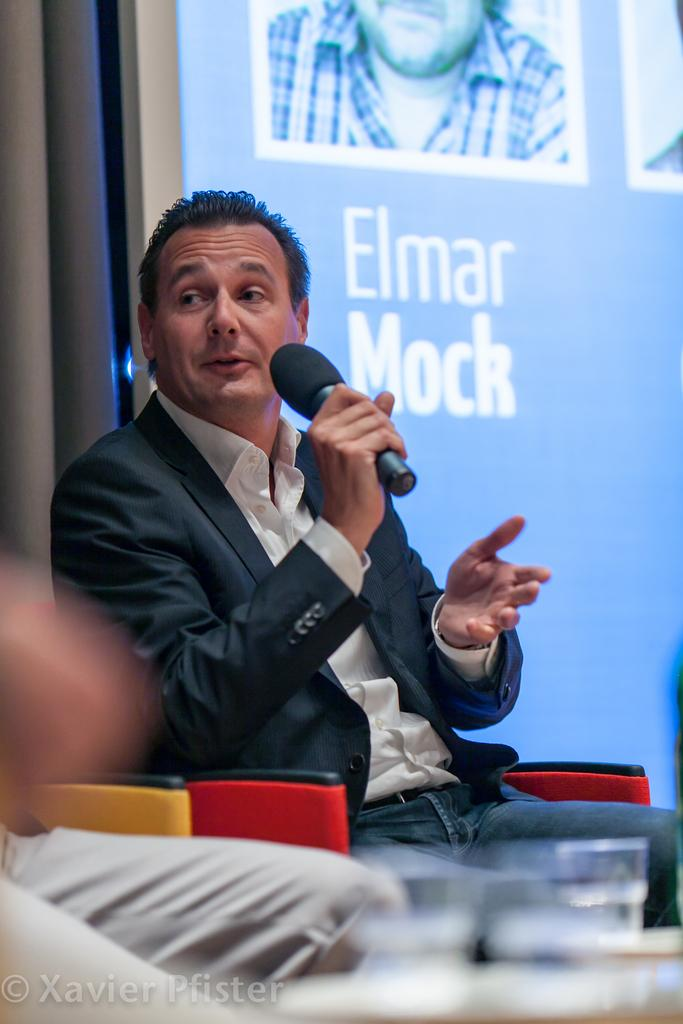Who is the main subject in the image? There is a man in the image. What is the man doing in the image? The man is sitting and speaking. What object is the man holding in his hand? The man is holding a microphone in his hand. What can be seen behind the man in the image? There is a screen behind the man. What type of mint is growing on the actor's lace in the image? There is no actor, lace, or mint present in the image. 